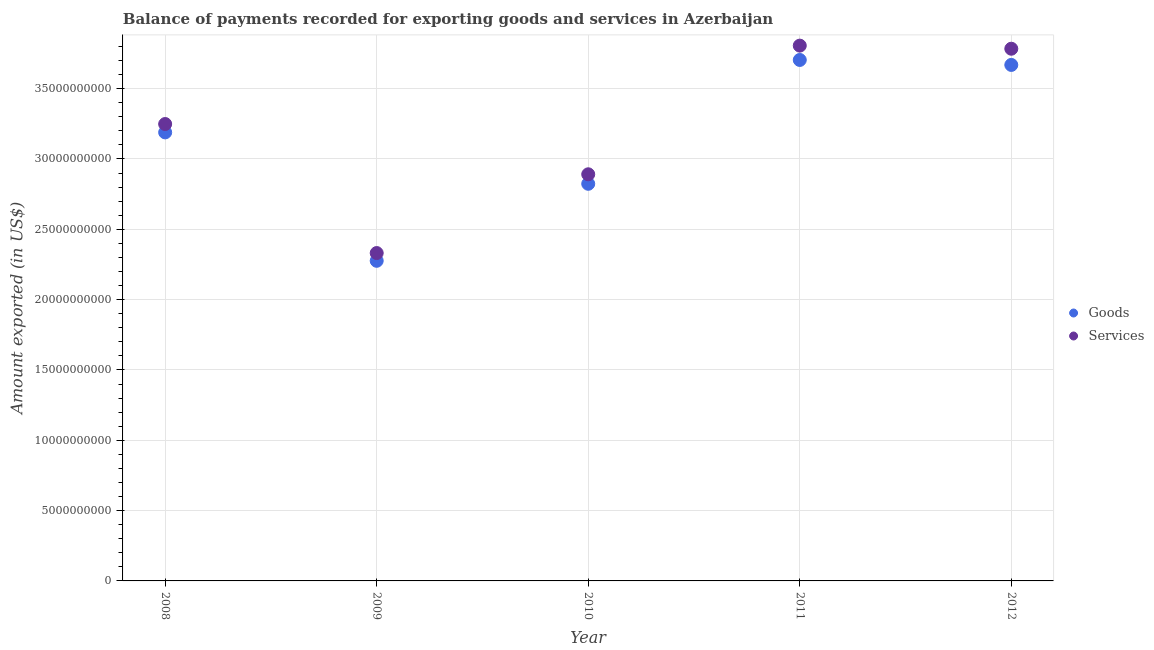Is the number of dotlines equal to the number of legend labels?
Keep it short and to the point. Yes. What is the amount of goods exported in 2011?
Offer a very short reply. 3.70e+1. Across all years, what is the maximum amount of goods exported?
Keep it short and to the point. 3.70e+1. Across all years, what is the minimum amount of services exported?
Give a very brief answer. 2.33e+1. In which year was the amount of services exported minimum?
Ensure brevity in your answer.  2009. What is the total amount of services exported in the graph?
Give a very brief answer. 1.61e+11. What is the difference between the amount of services exported in 2008 and that in 2012?
Give a very brief answer. -5.35e+09. What is the difference between the amount of goods exported in 2010 and the amount of services exported in 2008?
Ensure brevity in your answer.  -4.25e+09. What is the average amount of services exported per year?
Make the answer very short. 3.21e+1. In the year 2008, what is the difference between the amount of goods exported and amount of services exported?
Give a very brief answer. -5.95e+08. In how many years, is the amount of services exported greater than 3000000000 US$?
Offer a terse response. 5. What is the ratio of the amount of services exported in 2010 to that in 2012?
Provide a succinct answer. 0.76. Is the amount of goods exported in 2008 less than that in 2012?
Make the answer very short. Yes. What is the difference between the highest and the second highest amount of services exported?
Your answer should be very brief. 2.20e+08. What is the difference between the highest and the lowest amount of goods exported?
Ensure brevity in your answer.  1.43e+1. In how many years, is the amount of services exported greater than the average amount of services exported taken over all years?
Keep it short and to the point. 3. Is the sum of the amount of goods exported in 2011 and 2012 greater than the maximum amount of services exported across all years?
Provide a short and direct response. Yes. Does the amount of goods exported monotonically increase over the years?
Provide a succinct answer. No. How many dotlines are there?
Offer a very short reply. 2. What is the difference between two consecutive major ticks on the Y-axis?
Your response must be concise. 5.00e+09. Where does the legend appear in the graph?
Ensure brevity in your answer.  Center right. How are the legend labels stacked?
Offer a very short reply. Vertical. What is the title of the graph?
Provide a succinct answer. Balance of payments recorded for exporting goods and services in Azerbaijan. What is the label or title of the Y-axis?
Offer a very short reply. Amount exported (in US$). What is the Amount exported (in US$) of Goods in 2008?
Offer a very short reply. 3.19e+1. What is the Amount exported (in US$) in Services in 2008?
Make the answer very short. 3.25e+1. What is the Amount exported (in US$) of Goods in 2009?
Make the answer very short. 2.28e+1. What is the Amount exported (in US$) in Services in 2009?
Your answer should be compact. 2.33e+1. What is the Amount exported (in US$) in Goods in 2010?
Your answer should be very brief. 2.82e+1. What is the Amount exported (in US$) of Services in 2010?
Provide a short and direct response. 2.89e+1. What is the Amount exported (in US$) in Goods in 2011?
Make the answer very short. 3.70e+1. What is the Amount exported (in US$) of Services in 2011?
Provide a succinct answer. 3.81e+1. What is the Amount exported (in US$) of Goods in 2012?
Ensure brevity in your answer.  3.67e+1. What is the Amount exported (in US$) of Services in 2012?
Provide a short and direct response. 3.78e+1. Across all years, what is the maximum Amount exported (in US$) of Goods?
Make the answer very short. 3.70e+1. Across all years, what is the maximum Amount exported (in US$) of Services?
Provide a succinct answer. 3.81e+1. Across all years, what is the minimum Amount exported (in US$) in Goods?
Your answer should be compact. 2.28e+1. Across all years, what is the minimum Amount exported (in US$) in Services?
Give a very brief answer. 2.33e+1. What is the total Amount exported (in US$) in Goods in the graph?
Provide a short and direct response. 1.57e+11. What is the total Amount exported (in US$) of Services in the graph?
Your answer should be very brief. 1.61e+11. What is the difference between the Amount exported (in US$) of Goods in 2008 and that in 2009?
Your answer should be very brief. 9.13e+09. What is the difference between the Amount exported (in US$) in Services in 2008 and that in 2009?
Keep it short and to the point. 9.17e+09. What is the difference between the Amount exported (in US$) in Goods in 2008 and that in 2010?
Your response must be concise. 3.65e+09. What is the difference between the Amount exported (in US$) in Services in 2008 and that in 2010?
Offer a very short reply. 3.57e+09. What is the difference between the Amount exported (in US$) in Goods in 2008 and that in 2011?
Offer a terse response. -5.15e+09. What is the difference between the Amount exported (in US$) in Services in 2008 and that in 2011?
Keep it short and to the point. -5.57e+09. What is the difference between the Amount exported (in US$) of Goods in 2008 and that in 2012?
Provide a short and direct response. -4.80e+09. What is the difference between the Amount exported (in US$) of Services in 2008 and that in 2012?
Make the answer very short. -5.35e+09. What is the difference between the Amount exported (in US$) of Goods in 2009 and that in 2010?
Your answer should be compact. -5.48e+09. What is the difference between the Amount exported (in US$) in Services in 2009 and that in 2010?
Your answer should be compact. -5.60e+09. What is the difference between the Amount exported (in US$) in Goods in 2009 and that in 2011?
Make the answer very short. -1.43e+1. What is the difference between the Amount exported (in US$) of Services in 2009 and that in 2011?
Provide a short and direct response. -1.47e+1. What is the difference between the Amount exported (in US$) in Goods in 2009 and that in 2012?
Your answer should be compact. -1.39e+1. What is the difference between the Amount exported (in US$) in Services in 2009 and that in 2012?
Give a very brief answer. -1.45e+1. What is the difference between the Amount exported (in US$) in Goods in 2010 and that in 2011?
Your answer should be very brief. -8.80e+09. What is the difference between the Amount exported (in US$) of Services in 2010 and that in 2011?
Provide a short and direct response. -9.15e+09. What is the difference between the Amount exported (in US$) in Goods in 2010 and that in 2012?
Offer a terse response. -8.45e+09. What is the difference between the Amount exported (in US$) in Services in 2010 and that in 2012?
Provide a succinct answer. -8.93e+09. What is the difference between the Amount exported (in US$) in Goods in 2011 and that in 2012?
Provide a succinct answer. 3.53e+08. What is the difference between the Amount exported (in US$) in Services in 2011 and that in 2012?
Give a very brief answer. 2.20e+08. What is the difference between the Amount exported (in US$) of Goods in 2008 and the Amount exported (in US$) of Services in 2009?
Offer a very short reply. 8.58e+09. What is the difference between the Amount exported (in US$) of Goods in 2008 and the Amount exported (in US$) of Services in 2010?
Offer a terse response. 2.98e+09. What is the difference between the Amount exported (in US$) in Goods in 2008 and the Amount exported (in US$) in Services in 2011?
Your answer should be very brief. -6.17e+09. What is the difference between the Amount exported (in US$) of Goods in 2008 and the Amount exported (in US$) of Services in 2012?
Your answer should be compact. -5.95e+09. What is the difference between the Amount exported (in US$) in Goods in 2009 and the Amount exported (in US$) in Services in 2010?
Offer a very short reply. -6.15e+09. What is the difference between the Amount exported (in US$) in Goods in 2009 and the Amount exported (in US$) in Services in 2011?
Provide a short and direct response. -1.53e+1. What is the difference between the Amount exported (in US$) in Goods in 2009 and the Amount exported (in US$) in Services in 2012?
Make the answer very short. -1.51e+1. What is the difference between the Amount exported (in US$) in Goods in 2010 and the Amount exported (in US$) in Services in 2011?
Offer a terse response. -9.82e+09. What is the difference between the Amount exported (in US$) in Goods in 2010 and the Amount exported (in US$) in Services in 2012?
Make the answer very short. -9.60e+09. What is the difference between the Amount exported (in US$) of Goods in 2011 and the Amount exported (in US$) of Services in 2012?
Your answer should be very brief. -7.99e+08. What is the average Amount exported (in US$) in Goods per year?
Provide a succinct answer. 3.13e+1. What is the average Amount exported (in US$) of Services per year?
Provide a short and direct response. 3.21e+1. In the year 2008, what is the difference between the Amount exported (in US$) of Goods and Amount exported (in US$) of Services?
Offer a very short reply. -5.95e+08. In the year 2009, what is the difference between the Amount exported (in US$) of Goods and Amount exported (in US$) of Services?
Keep it short and to the point. -5.51e+08. In the year 2010, what is the difference between the Amount exported (in US$) in Goods and Amount exported (in US$) in Services?
Provide a succinct answer. -6.76e+08. In the year 2011, what is the difference between the Amount exported (in US$) in Goods and Amount exported (in US$) in Services?
Make the answer very short. -1.02e+09. In the year 2012, what is the difference between the Amount exported (in US$) of Goods and Amount exported (in US$) of Services?
Your response must be concise. -1.15e+09. What is the ratio of the Amount exported (in US$) in Goods in 2008 to that in 2009?
Your answer should be compact. 1.4. What is the ratio of the Amount exported (in US$) in Services in 2008 to that in 2009?
Offer a terse response. 1.39. What is the ratio of the Amount exported (in US$) of Goods in 2008 to that in 2010?
Provide a succinct answer. 1.13. What is the ratio of the Amount exported (in US$) in Services in 2008 to that in 2010?
Offer a terse response. 1.12. What is the ratio of the Amount exported (in US$) in Goods in 2008 to that in 2011?
Your answer should be very brief. 0.86. What is the ratio of the Amount exported (in US$) in Services in 2008 to that in 2011?
Your answer should be very brief. 0.85. What is the ratio of the Amount exported (in US$) of Goods in 2008 to that in 2012?
Provide a succinct answer. 0.87. What is the ratio of the Amount exported (in US$) of Services in 2008 to that in 2012?
Your response must be concise. 0.86. What is the ratio of the Amount exported (in US$) of Goods in 2009 to that in 2010?
Keep it short and to the point. 0.81. What is the ratio of the Amount exported (in US$) in Services in 2009 to that in 2010?
Ensure brevity in your answer.  0.81. What is the ratio of the Amount exported (in US$) of Goods in 2009 to that in 2011?
Offer a very short reply. 0.61. What is the ratio of the Amount exported (in US$) of Services in 2009 to that in 2011?
Provide a short and direct response. 0.61. What is the ratio of the Amount exported (in US$) of Goods in 2009 to that in 2012?
Give a very brief answer. 0.62. What is the ratio of the Amount exported (in US$) in Services in 2009 to that in 2012?
Ensure brevity in your answer.  0.62. What is the ratio of the Amount exported (in US$) of Goods in 2010 to that in 2011?
Provide a succinct answer. 0.76. What is the ratio of the Amount exported (in US$) of Services in 2010 to that in 2011?
Offer a terse response. 0.76. What is the ratio of the Amount exported (in US$) in Goods in 2010 to that in 2012?
Keep it short and to the point. 0.77. What is the ratio of the Amount exported (in US$) in Services in 2010 to that in 2012?
Ensure brevity in your answer.  0.76. What is the ratio of the Amount exported (in US$) in Goods in 2011 to that in 2012?
Provide a short and direct response. 1.01. What is the difference between the highest and the second highest Amount exported (in US$) of Goods?
Offer a very short reply. 3.53e+08. What is the difference between the highest and the second highest Amount exported (in US$) of Services?
Make the answer very short. 2.20e+08. What is the difference between the highest and the lowest Amount exported (in US$) of Goods?
Offer a terse response. 1.43e+1. What is the difference between the highest and the lowest Amount exported (in US$) in Services?
Your answer should be compact. 1.47e+1. 